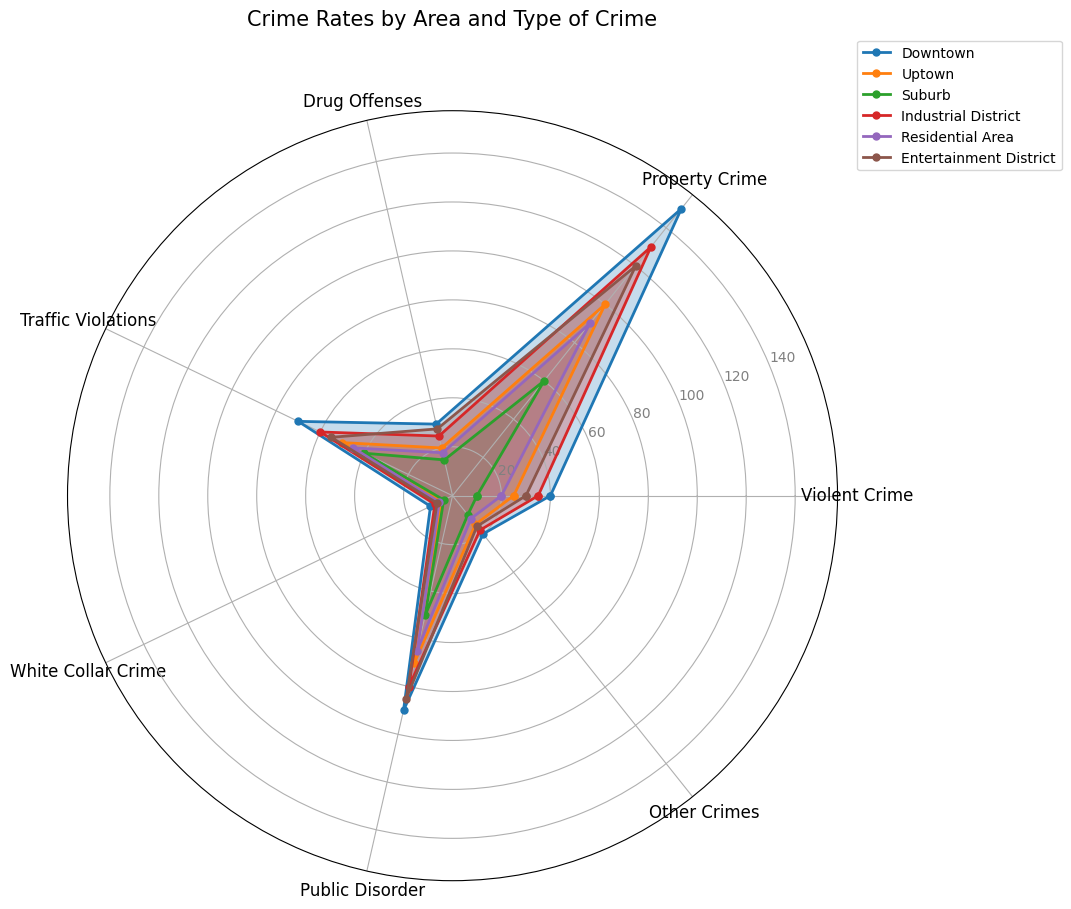Which area has the highest rate of violent crime? By looking at the length of the markers on the radar chart for the Violent Crime axis, we can see which one extends the most. The Downtown area has the highest rate with a value of 40.
Answer: Downtown Which two areas have the closest rates of property crime? By comparing the lengths of the markers on the Property Crime axis, the closest rates are for the Residential Area and the Uptown, both having values of 90 and 100, respectively.
Answer: Residential Area, Uptown What is the average rate of drug offenses across the areas? The rates of drug offenses are 30, 20, 15, 25, 18, and 28. Summing these (30 + 20 + 15 + 25 + 18 + 28) gives 136. Dividing this by the 6 areas gives an average rate of 22.67.
Answer: 22.67 Which area demonstrates the most variability in crime rates across different types of crime? By looking at the variation in the radar chart spokes, Downtown has the highest spread; it has the highest rate of Violent Crime (40) and Public Disorder (90), while relatively low rates for White Collar Crime (10).
Answer: Downtown Are traffic violations more common in the Downtown area or the Industrial District? By comparing the lengths of the markers for Traffic Violations, we see the Downtown area has a value of 70 whereas the Industrial District has a value of 60. Therefore, traffic violations are more common in the Downtown area.
Answer: Downtown Which area has the lowest rate of public disorder? By examining the Public Disorder axis on the radar chart, the area with the shortest marker is Suburb, with a rate of 50.
Answer: Suburb How do the total crime rates (sum of all types of crime) compare between Downtown and Uptown? Summing up the rates for each area:
Downtown: 40 + 150 + 30 + 70 + 10 + 90 + 20 = 410
Uptown: 25 + 100 + 20 + 50 + 5 + 70 + 15 = 285. So, Downtown has a higher total crime rate.
Answer: Downtown: 410, Uptown: 285 What is the median rate of traffic violations across all areas? The rates for Traffic Violations are 70, 50, 40, 60, 45, and 55. Arranging these in ascending order (40, 45, 50, 55, 60, 70) and taking the middle values gives (50 + 55)/2 = 52.5.
Answer: 52.5 